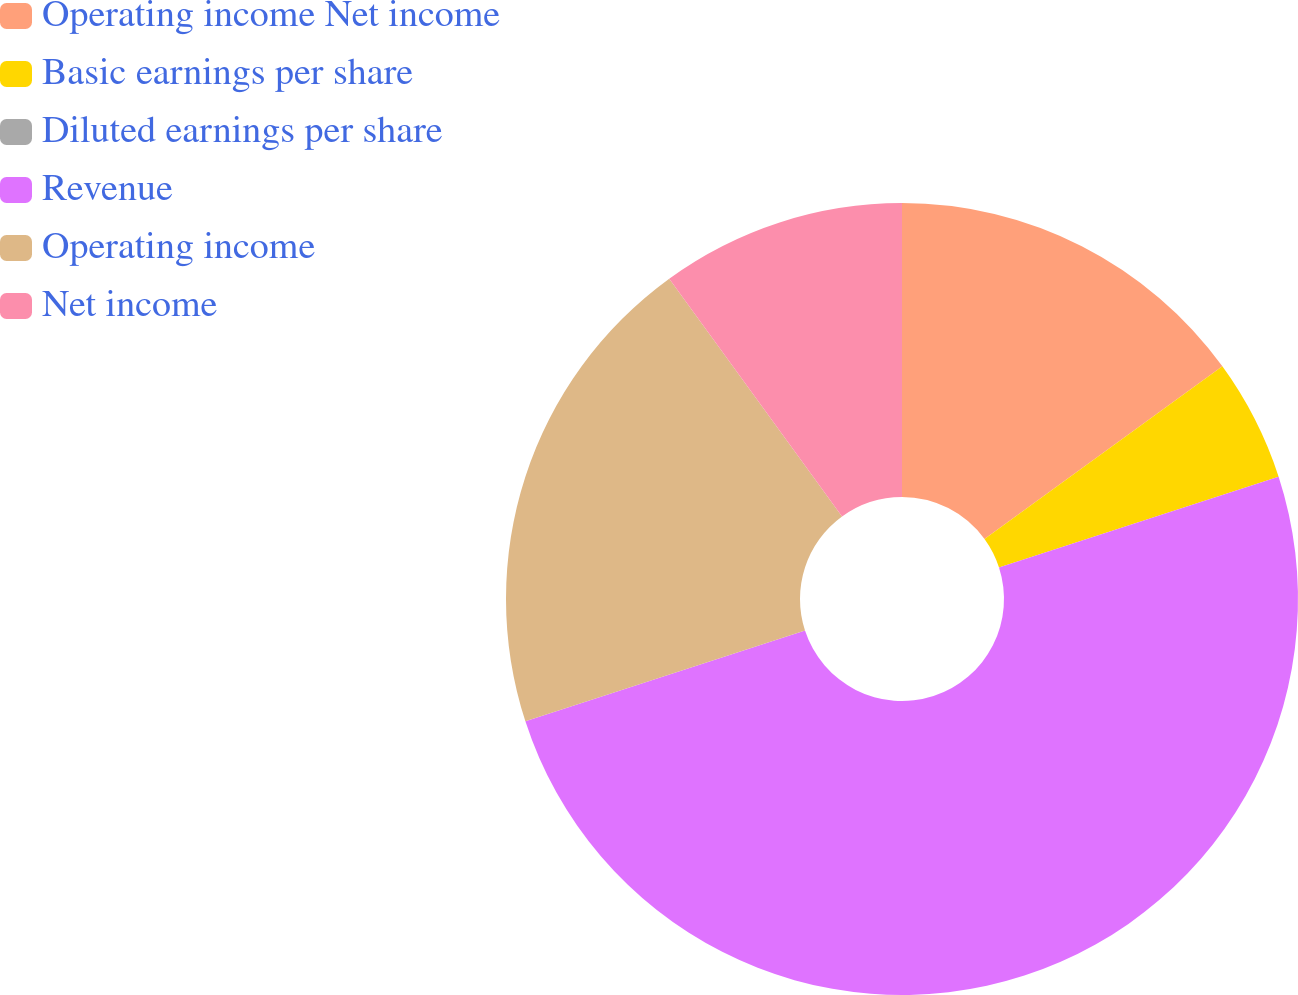Convert chart. <chart><loc_0><loc_0><loc_500><loc_500><pie_chart><fcel>Operating income Net income<fcel>Basic earnings per share<fcel>Diluted earnings per share<fcel>Revenue<fcel>Operating income<fcel>Net income<nl><fcel>15.0%<fcel>5.0%<fcel>0.0%<fcel>50.0%<fcel>20.0%<fcel>10.0%<nl></chart> 